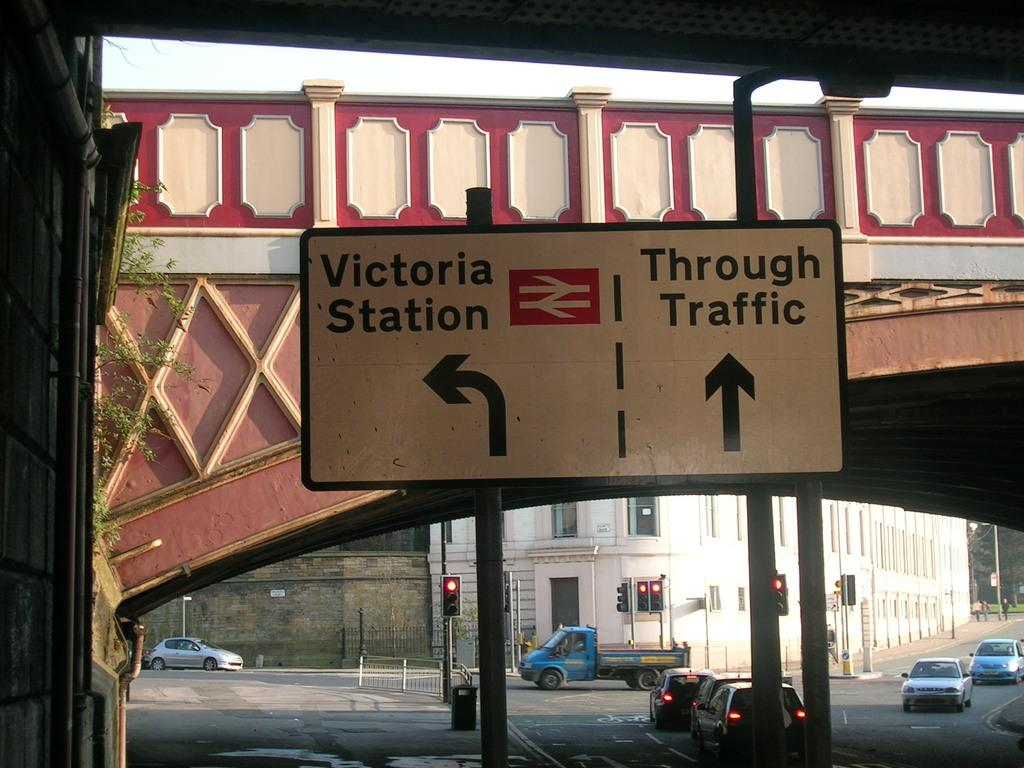<image>
Provide a brief description of the given image. Victoria Station is to the left and through traffic should proceed straight ahead. 